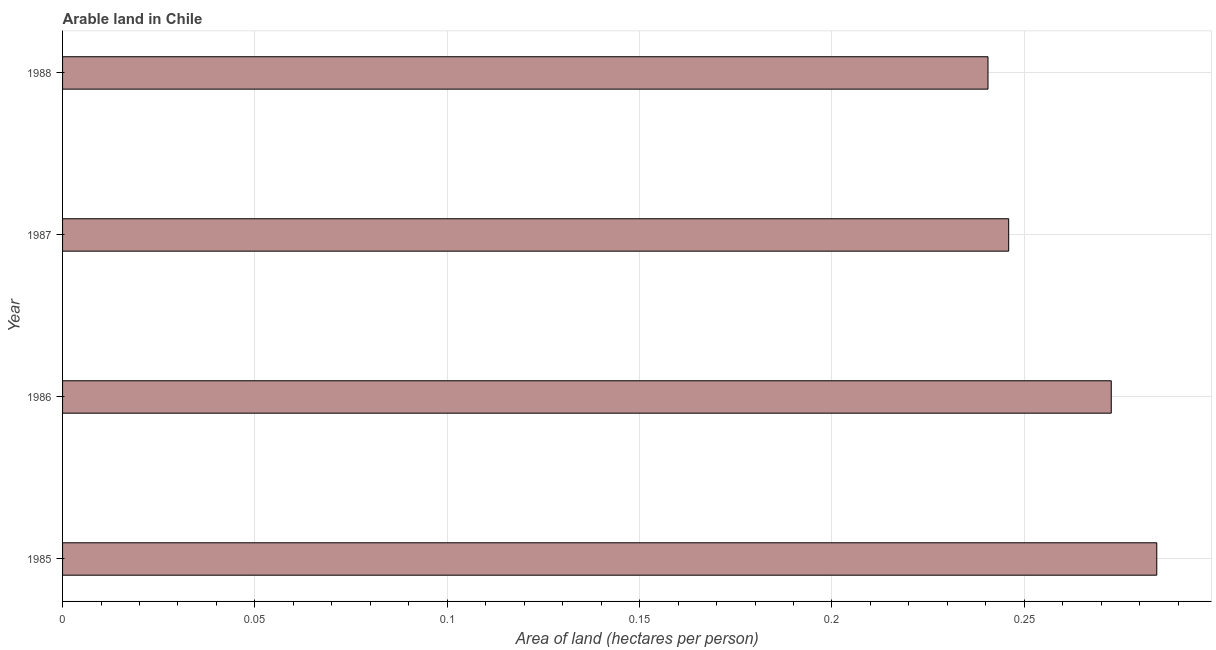Does the graph contain any zero values?
Make the answer very short. No. What is the title of the graph?
Provide a short and direct response. Arable land in Chile. What is the label or title of the X-axis?
Offer a terse response. Area of land (hectares per person). What is the label or title of the Y-axis?
Keep it short and to the point. Year. What is the area of arable land in 1988?
Offer a very short reply. 0.24. Across all years, what is the maximum area of arable land?
Offer a terse response. 0.28. Across all years, what is the minimum area of arable land?
Ensure brevity in your answer.  0.24. What is the sum of the area of arable land?
Provide a short and direct response. 1.04. What is the difference between the area of arable land in 1985 and 1987?
Your answer should be compact. 0.04. What is the average area of arable land per year?
Ensure brevity in your answer.  0.26. What is the median area of arable land?
Your answer should be very brief. 0.26. What is the ratio of the area of arable land in 1985 to that in 1986?
Your answer should be compact. 1.04. Is the area of arable land in 1986 less than that in 1988?
Offer a terse response. No. What is the difference between the highest and the second highest area of arable land?
Keep it short and to the point. 0.01. How many bars are there?
Provide a short and direct response. 4. Are all the bars in the graph horizontal?
Provide a short and direct response. Yes. How many years are there in the graph?
Make the answer very short. 4. What is the difference between two consecutive major ticks on the X-axis?
Give a very brief answer. 0.05. What is the Area of land (hectares per person) of 1985?
Provide a short and direct response. 0.28. What is the Area of land (hectares per person) of 1986?
Offer a very short reply. 0.27. What is the Area of land (hectares per person) of 1987?
Provide a succinct answer. 0.25. What is the Area of land (hectares per person) in 1988?
Ensure brevity in your answer.  0.24. What is the difference between the Area of land (hectares per person) in 1985 and 1986?
Your answer should be compact. 0.01. What is the difference between the Area of land (hectares per person) in 1985 and 1987?
Provide a succinct answer. 0.04. What is the difference between the Area of land (hectares per person) in 1985 and 1988?
Make the answer very short. 0.04. What is the difference between the Area of land (hectares per person) in 1986 and 1987?
Your answer should be compact. 0.03. What is the difference between the Area of land (hectares per person) in 1986 and 1988?
Your answer should be very brief. 0.03. What is the difference between the Area of land (hectares per person) in 1987 and 1988?
Give a very brief answer. 0.01. What is the ratio of the Area of land (hectares per person) in 1985 to that in 1986?
Provide a short and direct response. 1.04. What is the ratio of the Area of land (hectares per person) in 1985 to that in 1987?
Ensure brevity in your answer.  1.16. What is the ratio of the Area of land (hectares per person) in 1985 to that in 1988?
Ensure brevity in your answer.  1.18. What is the ratio of the Area of land (hectares per person) in 1986 to that in 1987?
Your answer should be very brief. 1.11. What is the ratio of the Area of land (hectares per person) in 1986 to that in 1988?
Keep it short and to the point. 1.13. What is the ratio of the Area of land (hectares per person) in 1987 to that in 1988?
Your answer should be compact. 1.02. 